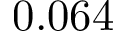Convert formula to latex. <formula><loc_0><loc_0><loc_500><loc_500>0 . 0 6 4</formula> 